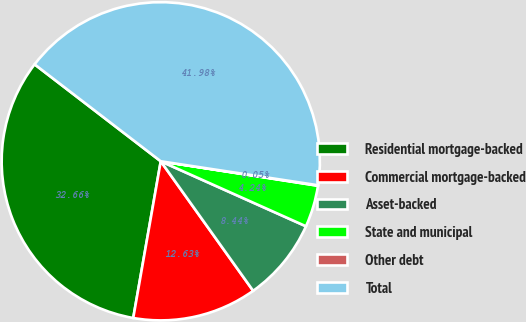Convert chart. <chart><loc_0><loc_0><loc_500><loc_500><pie_chart><fcel>Residential mortgage-backed<fcel>Commercial mortgage-backed<fcel>Asset-backed<fcel>State and municipal<fcel>Other debt<fcel>Total<nl><fcel>32.66%<fcel>12.63%<fcel>8.44%<fcel>4.24%<fcel>0.05%<fcel>41.98%<nl></chart> 